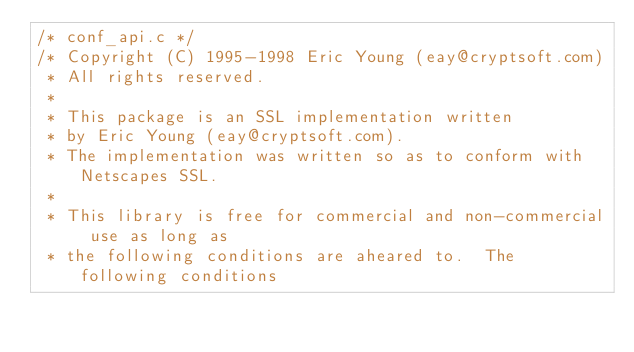<code> <loc_0><loc_0><loc_500><loc_500><_C_>/* conf_api.c */
/* Copyright (C) 1995-1998 Eric Young (eay@cryptsoft.com)
 * All rights reserved.
 *
 * This package is an SSL implementation written
 * by Eric Young (eay@cryptsoft.com).
 * The implementation was written so as to conform with Netscapes SSL.
 *
 * This library is free for commercial and non-commercial use as long as
 * the following conditions are aheared to.  The following conditions</code> 